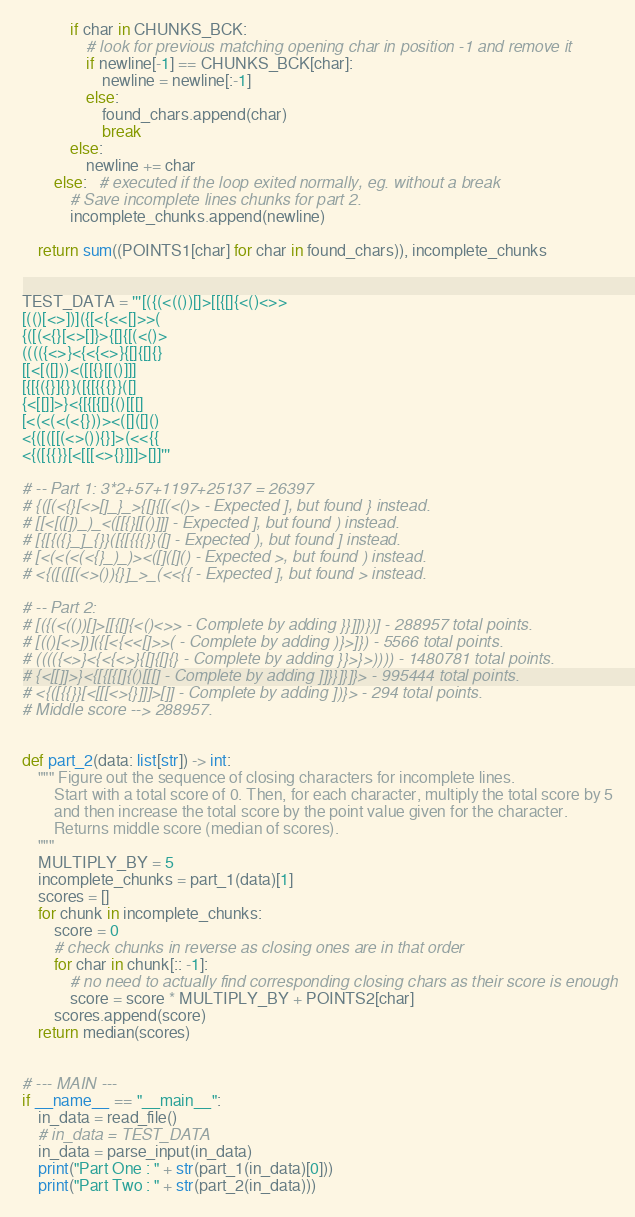Convert code to text. <code><loc_0><loc_0><loc_500><loc_500><_Python_>            if char in CHUNKS_BCK:
                # look for previous matching opening char in position -1 and remove it
                if newline[-1] == CHUNKS_BCK[char]:
                    newline = newline[:-1]
                else:
                    found_chars.append(char)
                    break
            else:
                newline += char
        else:   # executed if the loop exited normally, eg. without a break
            # Save incomplete lines chunks for part 2.
            incomplete_chunks.append(newline)

    return sum((POINTS1[char] for char in found_chars)), incomplete_chunks


TEST_DATA = '''[({(<(())[]>[[{[]{<()<>>
[(()[<>])]({[<{<<[]>>(
{([(<{}[<>[]}>{[]{[(<()>
(((({<>}<{<{<>}{[]{[]{}
[[<[([]))<([[{}[[()]]]
[{[{({}]{}}([{[{{{}}([]
{<[[]]>}<{[{[{[]{()[[[]
[<(<(<(<{}))><([]([]()
<{([([[(<>()){}]>(<<{{
<{([{{}}[<[[[<>{}]]]>[]]'''

# -- Part 1: 3*2+57+1197+25137 = 26397
# {([(<{}[<>[]_}_>{[]{[(<()> - Expected ], but found } instead.
# [[<[([])_)_<([[{}[[()]]] - Expected ], but found ) instead.
# [{[{({}_]_{}}([{[{{{}}([] - Expected ), but found ] instead.
# [<(<(<(<{}_)_)><([]([]() - Expected >, but found ) instead.
# <{([([[(<>()){}]_>_(<<{{ - Expected ], but found > instead.

# -- Part 2:
# [({(<(())[]>[[{[]{<()<>> - Complete by adding }}]])})] - 288957 total points.
# [(()[<>])]({[<{<<[]>>( - Complete by adding )}>]}) - 5566 total points.
# (((({<>}<{<{<>}{[]{[]{} - Complete by adding }}>}>)))) - 1480781 total points.
# {<[[]]>}<{[{[{[]{()[[[] - Complete by adding ]]}}]}]}> - 995444 total points.
# <{([{{}}[<[[[<>{}]]]>[]] - Complete by adding ])}> - 294 total points.
# Middle score --> 288957.


def part_2(data: list[str]) -> int:
    """ Figure out the sequence of closing characters for incomplete lines. 
        Start with a total score of 0. Then, for each character, multiply the total score by 5
        and then increase the total score by the point value given for the character.
        Returns middle score (median of scores).
    """
    MULTIPLY_BY = 5
    incomplete_chunks = part_1(data)[1]
    scores = []
    for chunk in incomplete_chunks:
        score = 0
        # check chunks in reverse as closing ones are in that order
        for char in chunk[:: -1]:
            # no need to actually find corresponding closing chars as their score is enough
            score = score * MULTIPLY_BY + POINTS2[char]
        scores.append(score)
    return median(scores)


# --- MAIN ---
if __name__ == "__main__":
    in_data = read_file()
    # in_data = TEST_DATA
    in_data = parse_input(in_data)
    print("Part One : " + str(part_1(in_data)[0]))
    print("Part Two : " + str(part_2(in_data)))
</code> 